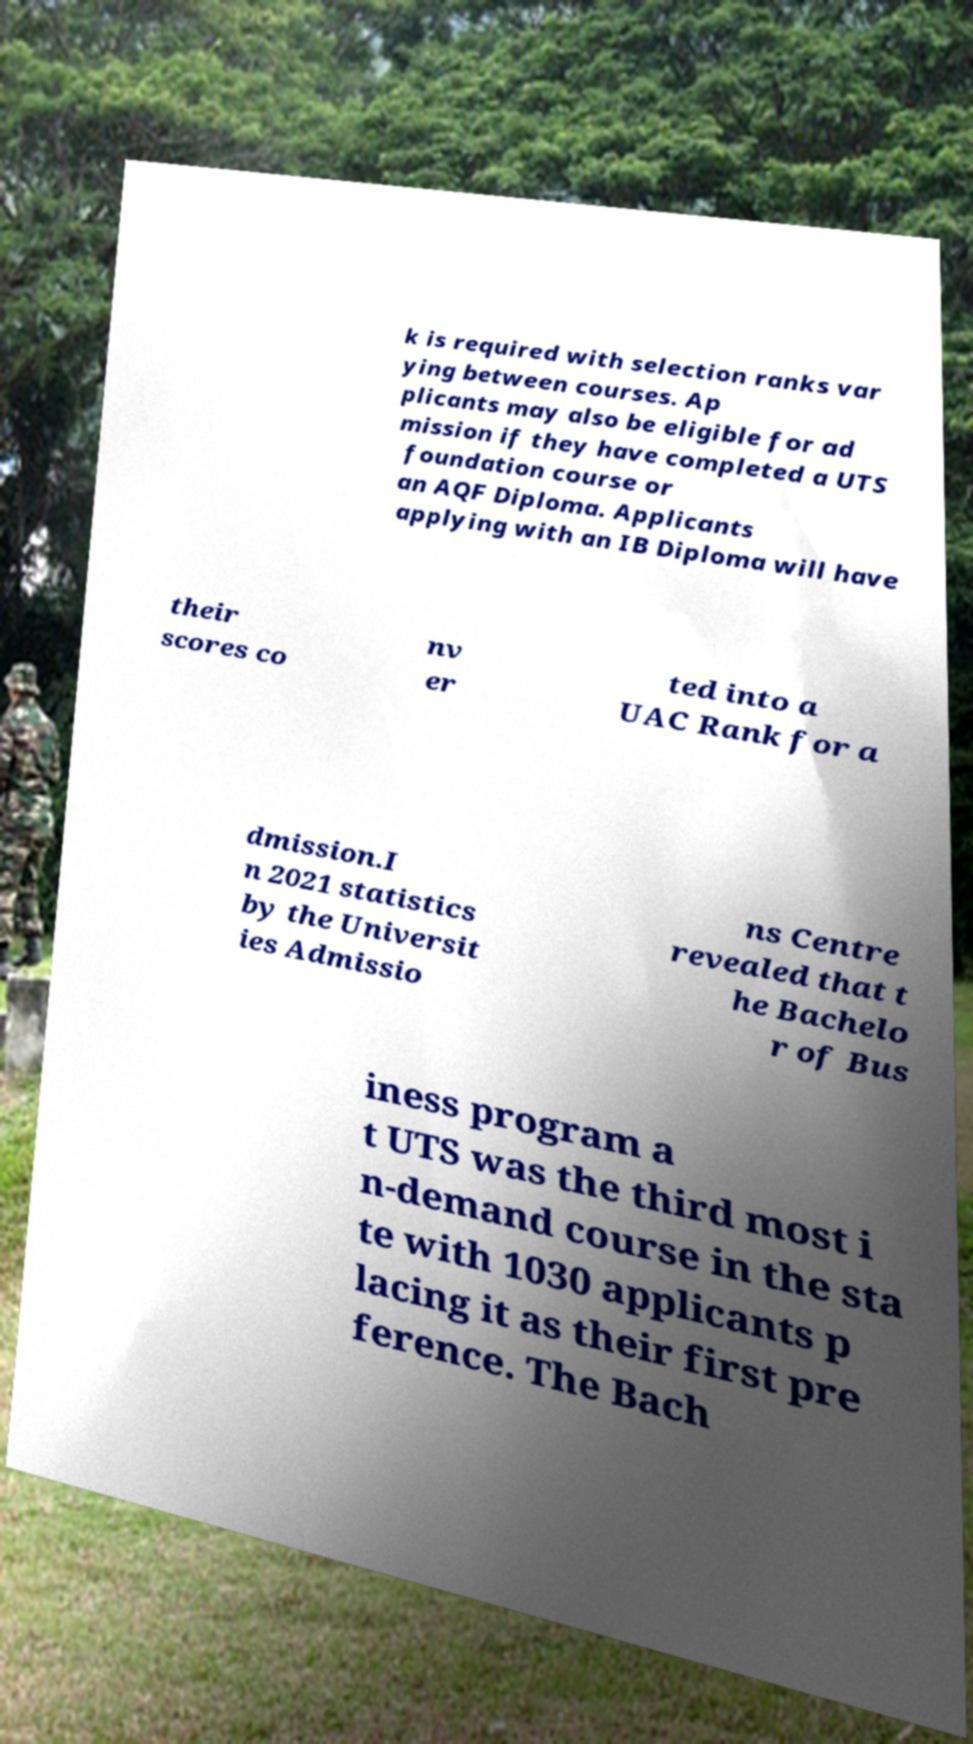There's text embedded in this image that I need extracted. Can you transcribe it verbatim? k is required with selection ranks var ying between courses. Ap plicants may also be eligible for ad mission if they have completed a UTS foundation course or an AQF Diploma. Applicants applying with an IB Diploma will have their scores co nv er ted into a UAC Rank for a dmission.I n 2021 statistics by the Universit ies Admissio ns Centre revealed that t he Bachelo r of Bus iness program a t UTS was the third most i n-demand course in the sta te with 1030 applicants p lacing it as their first pre ference. The Bach 